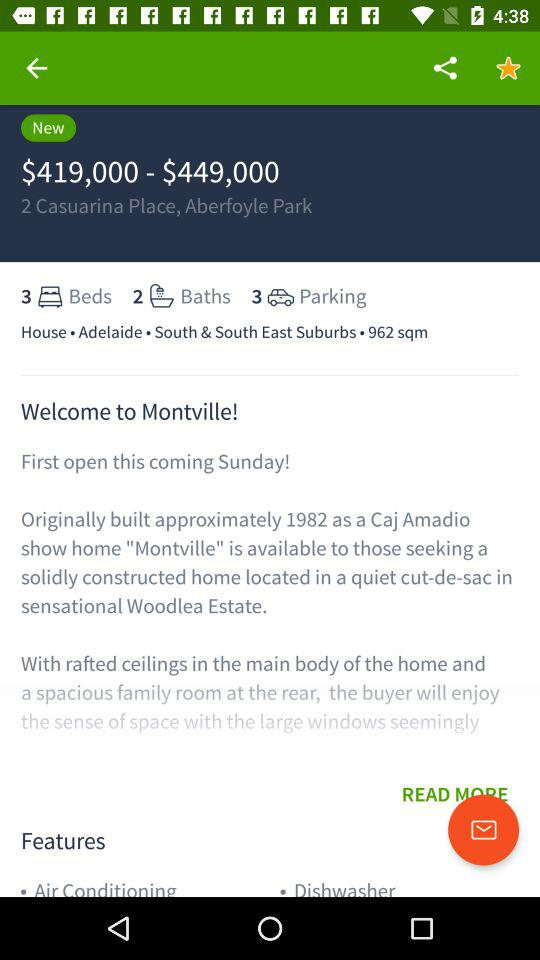How many beds are there? There are 3 beds. 